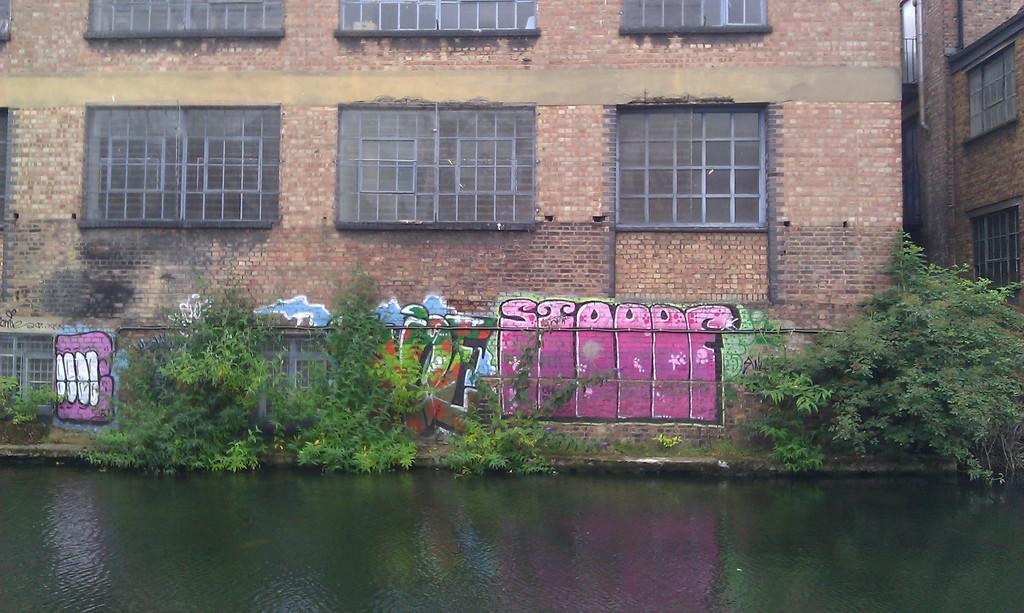Describe this image in one or two sentences. At the bottom of the image there is water and we can see plants. In the background there are buildings. 